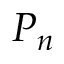Convert formula to latex. <formula><loc_0><loc_0><loc_500><loc_500>P _ { n }</formula> 